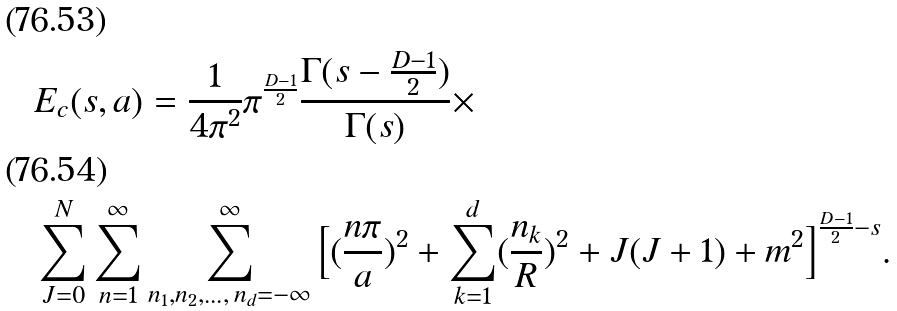<formula> <loc_0><loc_0><loc_500><loc_500>& E _ { c } ( s , a ) = \frac { 1 } { 4 \pi ^ { 2 } } \pi ^ { \frac { D - 1 } { 2 } } \frac { \Gamma ( s - \frac { D - 1 } { 2 } ) } { \Gamma ( s ) } \times \\ & \sum _ { J = 0 } ^ { N } \sum _ { n = 1 } ^ { \infty } \sum ^ { \infty } _ { n _ { 1 } , n _ { 2 } , \dots , { \, } n _ { d } = - \infty } \Big { [ } ( \frac { n \pi } { a } ) ^ { 2 } + \sum _ { k = 1 } ^ { d } ( \frac { n _ { k } } { R } ) ^ { 2 } + J ( J + 1 ) + m ^ { 2 } \Big { ] } ^ { \frac { D - 1 } { 2 } - s } .</formula> 